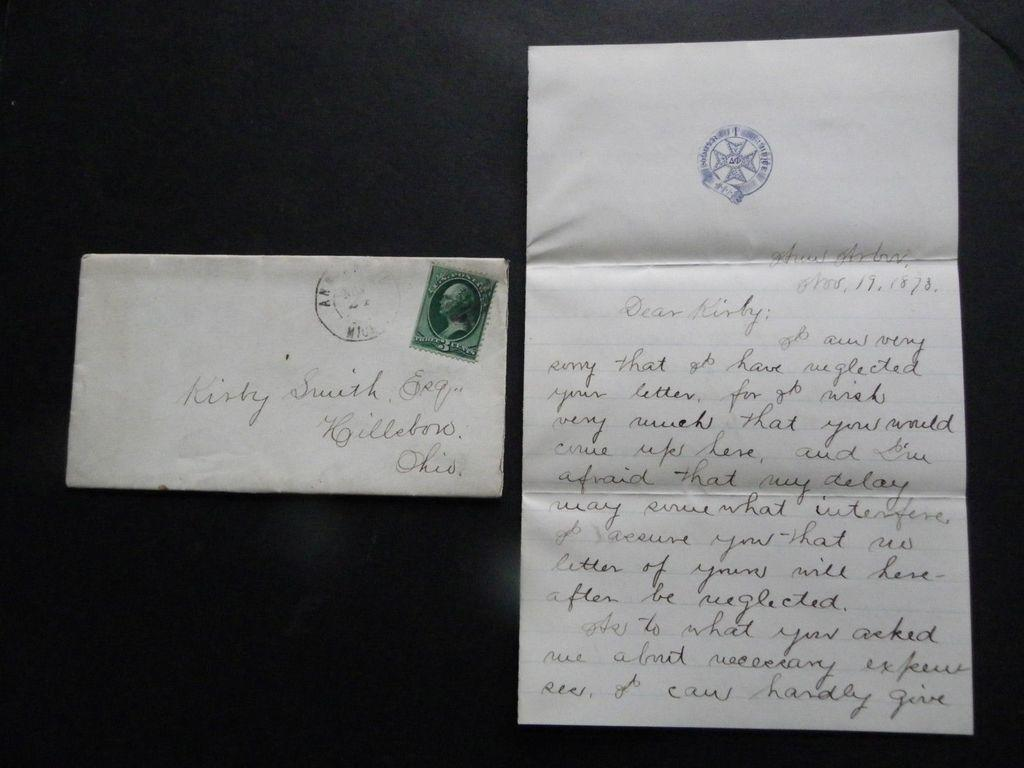<image>
Relay a brief, clear account of the picture shown. A very old letter was written to Kirby Smith. 